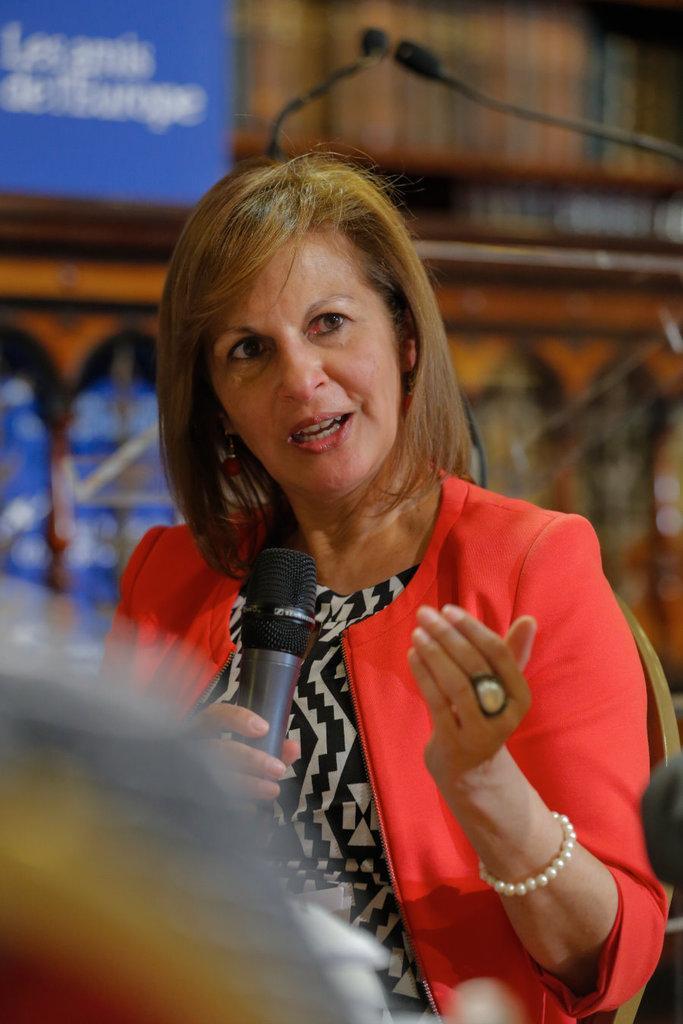Can you describe this image briefly? This picture shows a woman Seated on the chair and speaking with the help of a microphone. 